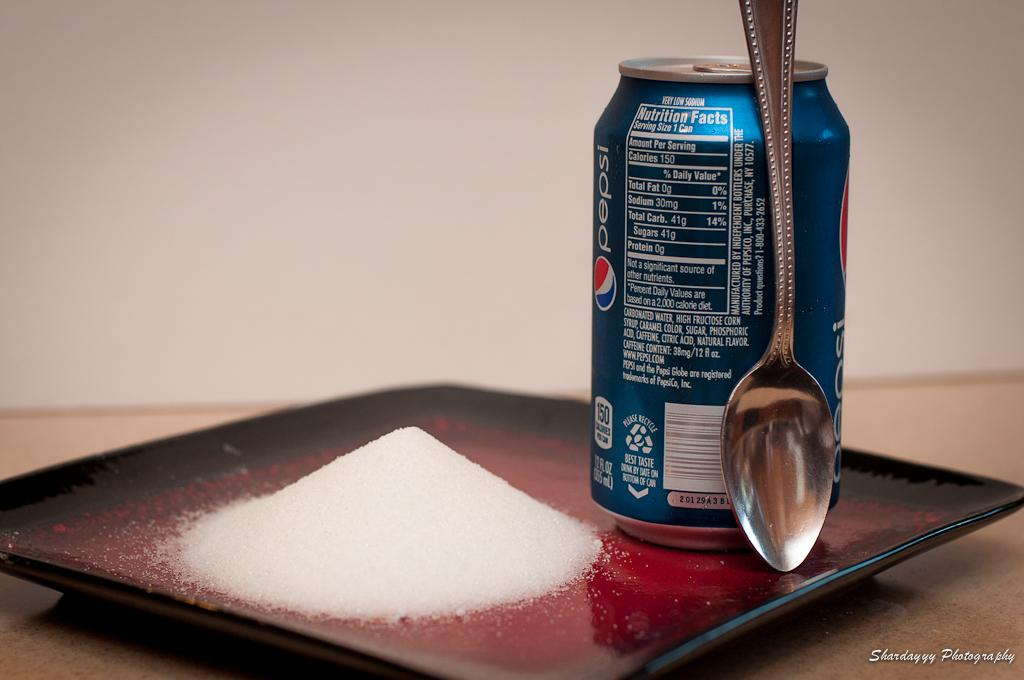<image>
Present a compact description of the photo's key features. A can of Pepsi with 150 calories sits on a table with a spoon leaned against it. 